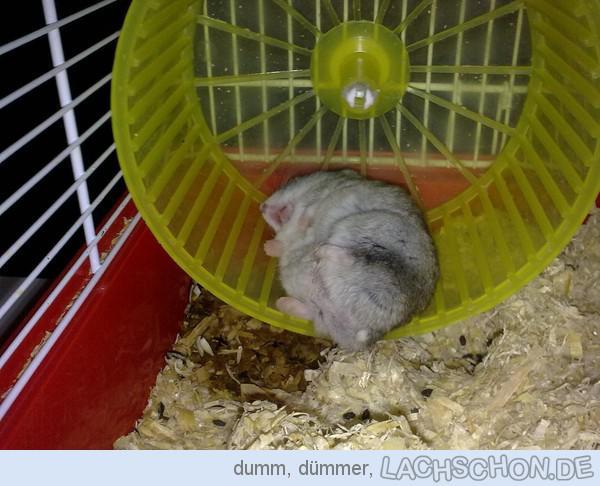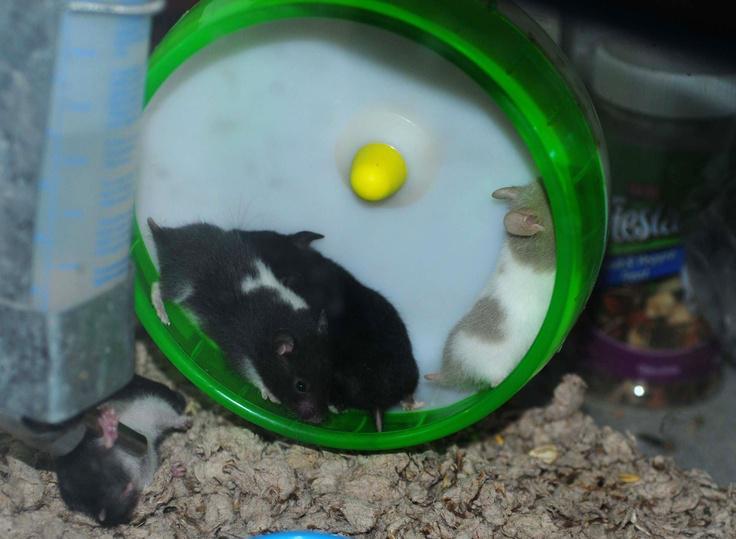The first image is the image on the left, the second image is the image on the right. Evaluate the accuracy of this statement regarding the images: "In one of the images, three hamsters are huddled together in a small space.". Is it true? Answer yes or no. No. The first image is the image on the left, the second image is the image on the right. Evaluate the accuracy of this statement regarding the images: "Each image shows a hamster in a wheel, and one image shows three hamsters in a wheel with non-mesh green sides.". Is it true? Answer yes or no. Yes. 